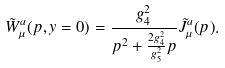<formula> <loc_0><loc_0><loc_500><loc_500>\tilde { W } ^ { a } _ { \mu } ( p , y = 0 ) = \frac { g _ { 4 } ^ { 2 } } { p ^ { 2 } + \frac { 2 g _ { 4 } ^ { 2 } } { g _ { 5 } ^ { 2 } } p } \tilde { J } ^ { a } _ { \mu } ( p ) .</formula> 